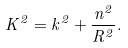Convert formula to latex. <formula><loc_0><loc_0><loc_500><loc_500>K ^ { 2 } = k ^ { 2 } + \frac { n ^ { 2 } } { R ^ { 2 } } .</formula> 